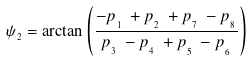Convert formula to latex. <formula><loc_0><loc_0><loc_500><loc_500>\psi _ { _ { 2 } } = \arctan \left ( \frac { - p _ { _ { _ { 1 } } } \, + p _ { _ { _ { 2 } } } \, + p _ { _ { _ { 7 } } } \, - p _ { _ { _ { 8 } } } } { p _ { _ { _ { 3 } } } \, - p _ { _ { _ { 4 } } } \, + p _ { _ { _ { 5 } } } \, - p _ { _ { _ { 6 } } } } \right )</formula> 